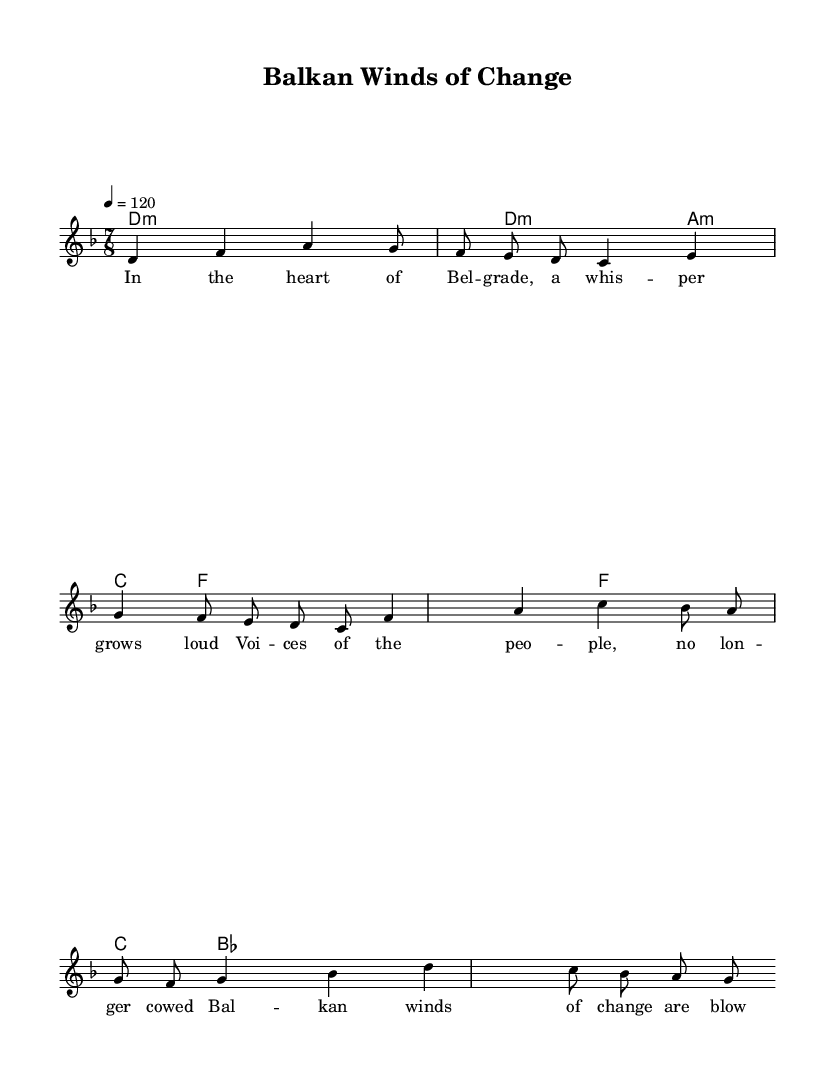What is the key signature of this music? The key signature is D minor, which contains one flat (B flat). This is indicated at the beginning of the staff.
Answer: D minor What is the time signature of this music? The time signature is 7/8, which is indicated at the beginning of the score. It shows that there are 7 beats in each measure, and an eighth note gets one beat.
Answer: 7/8 What is the tempo marking of this piece? The tempo marking is quarter note equals 120, which tells the performer to play at a speed of 120 beats per minute. This is also found at the beginning of the score.
Answer: 120 What is the structure of the song? The song consists of a verse followed by a chorus, as indicated by the placement of the lyrics and the melody breakdown. The lyrics under the melody reflect this structure quite clearly.
Answer: Verse and Chorus How many measures are in the verse? Counting the measures in the verse section of the melody, there are 2 measures of melody aligned with the lyrics, indicating a clear separation between the verse and chorus.
Answer: 2 What is the main theme of the lyrics? The main theme of the lyrics revolves around political reform and social justice, as reflected in phrases that speak to change and democracy. This aligns with the title of the piece, "Balkan Winds of Change."
Answer: Political reform What is the chord progression used in the chorus? The chorus features a chord progression of F major to C major and B flat major, which is typical in progressive rock for creating a rich harmonic texture. This progression supports the melody during the chorus part of the song.
Answer: F, C, B flat 